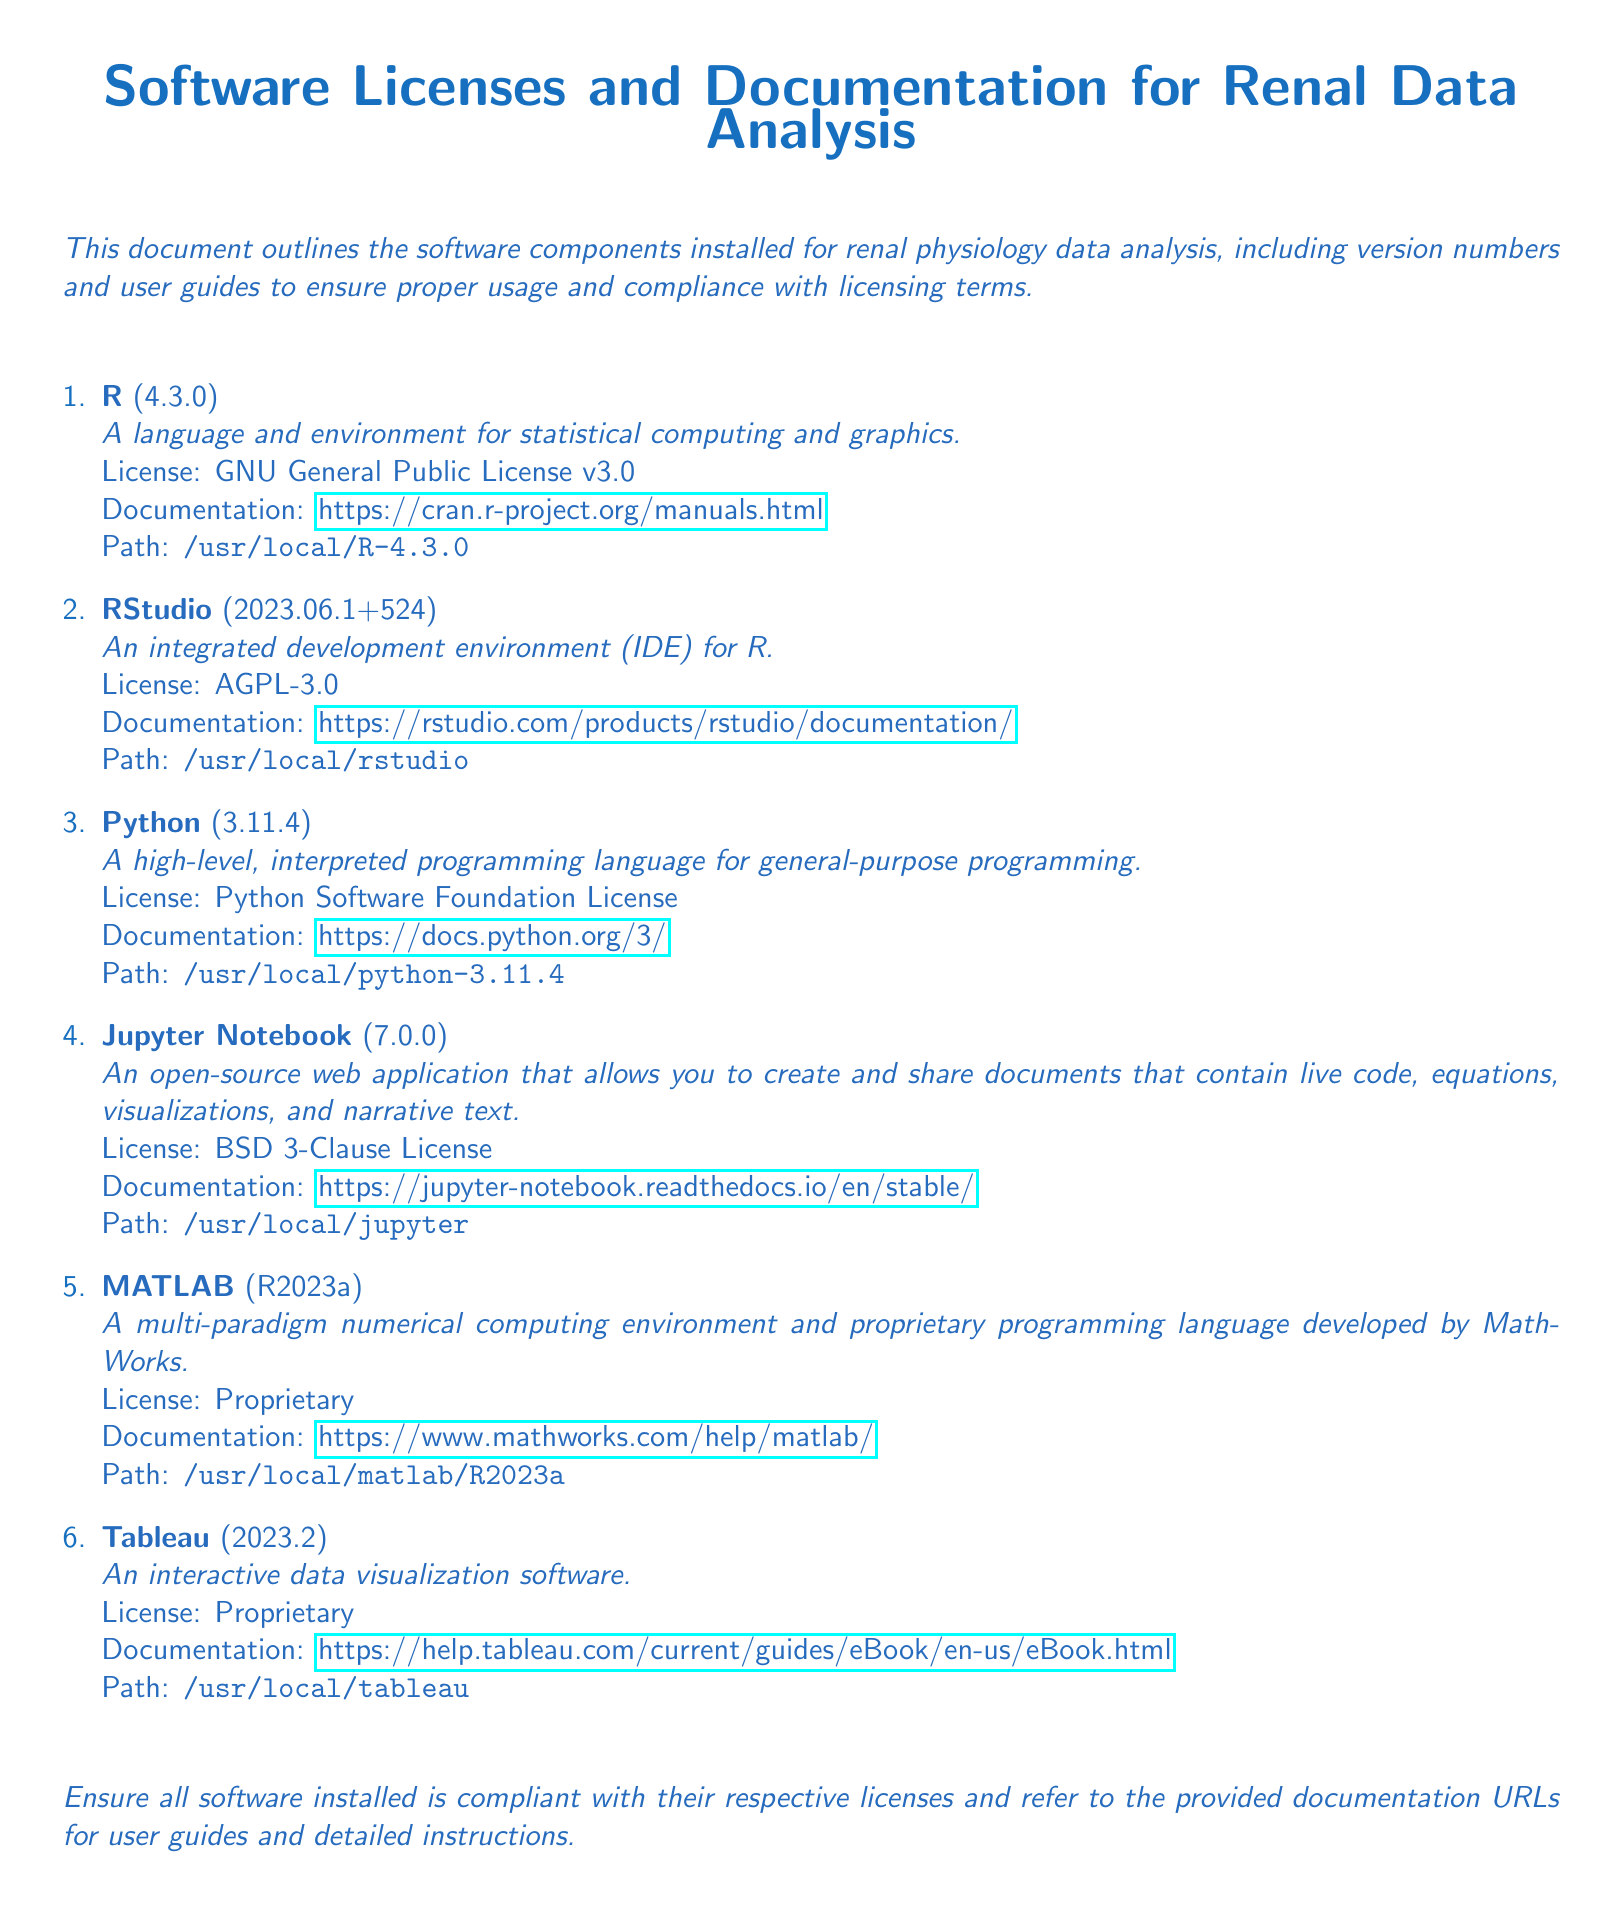What is the version of R? The version of R installed is specified in the document as 4.3.0.
Answer: 4.3.0 What is the license type for RStudio? The document indicates that RStudio is licensed under the AGPL-3.0.
Answer: AGPL-3.0 Which software has a BSD 3-Clause License? The document lists Jupyter Notebook as the software with a BSD 3-Clause License.
Answer: Jupyter Notebook How many software applications are listed in the document? The document enumerates a total of six software applications for renal data analysis.
Answer: Six What is the path for the installed MATLAB software? The path for MATLAB specified in the document is /usr/local/matlab/R2023a.
Answer: /usr/local/matlab/R2023a What documentation URL is provided for Python? The URL provided for Python documentation in the document is https://docs.python.org/3/.
Answer: https://docs.python.org/3/ What is the purpose of Tableau as per the document? The document describes Tableau as an interactive data visualization software.
Answer: Interactive data visualization software Which software is an integrated development environment for R? The software noted as an integrated development environment for R is RStudio.
Answer: RStudio What version of Jupyter Notebook is installed? The document states that the version of Jupyter Notebook installed is 7.0.0.
Answer: 7.0.0 